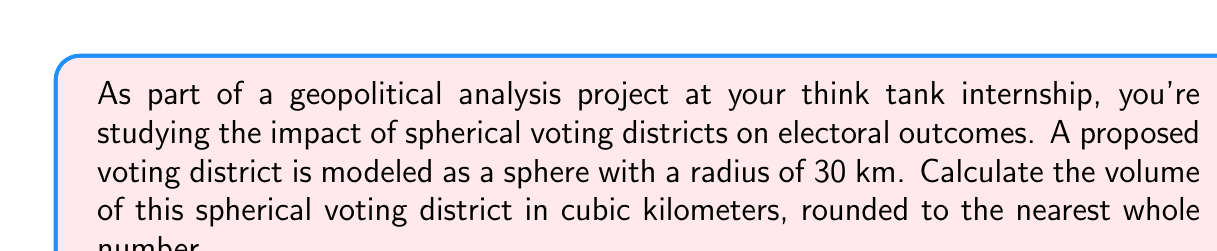Provide a solution to this math problem. To solve this problem, we need to use the formula for the volume of a sphere:

$$V = \frac{4}{3}\pi r^3$$

Where:
$V$ is the volume of the sphere
$r$ is the radius of the sphere

Given:
$r = 30$ km

Let's substitute this into our formula:

$$V = \frac{4}{3}\pi (30)^3$$

Now, let's calculate step-by-step:

1) First, calculate $30^3$:
   $30^3 = 30 \times 30 \times 30 = 27,000$

2) Our equation now looks like this:
   $$V = \frac{4}{3}\pi (27,000)$$

3) Multiply $\frac{4}{3}$ by 27,000:
   $$V = \frac{4 \times 27,000}{3}\pi = 36,000\pi$$

4) Now, let's multiply by $\pi$ (we'll use 3.14159 as an approximation):
   $$V = 36,000 \times 3.14159 = 113,097.24$$

5) Rounding to the nearest whole number:
   $V \approx 113,097$ cubic kilometers

This volume represents the size of the spherical voting district, which is crucial for understanding population distribution and potential voting patterns in geopolitical analysis.
Answer: 113,097 cubic kilometers 